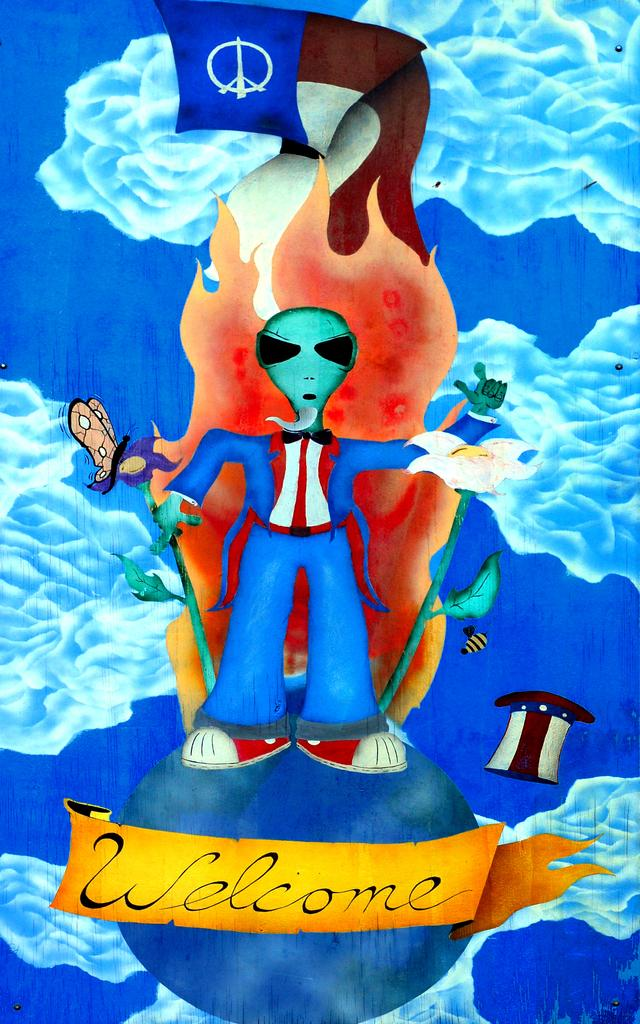What type of image is being described? The image appears to be an animation. What can be found at the bottom of the image? There is text at the bottom of the image. Who or what is in the middle of the image? There is a person standing in the middle of the image. What is on the left side of the image? There is a butterfly on the left side of the image. How many nails are visible in the image? There are no nails present in the image. What question is being asked by the person in the image? The image does not show the person asking a question, so we cannot determine what question they might be asking. 